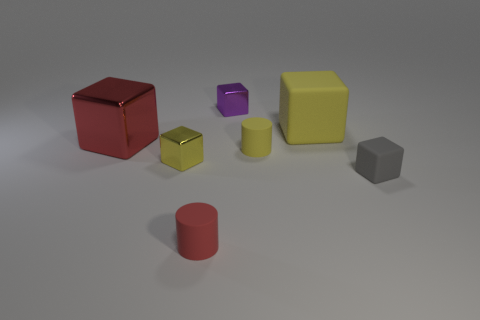What shadows are cast by the objects, and what can that tell us about the light source? The objects cast soft-edged shadows that extend towards the bottom-right of the image, indicating that the primary light source is positioned top-left of the scene and slightly in front. The shadows help us infer not only the position but also the diffuseness of the light, as sharp shadows would suggest a more focused light source. 